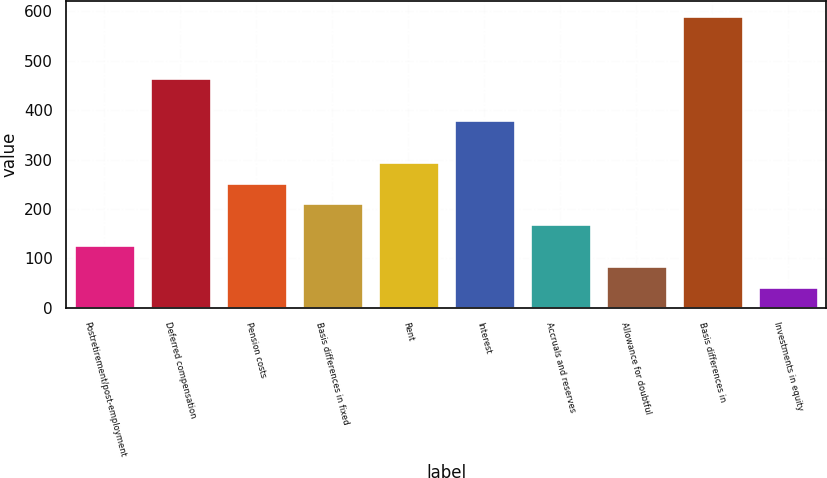Convert chart to OTSL. <chart><loc_0><loc_0><loc_500><loc_500><bar_chart><fcel>Postretirement/post-employment<fcel>Deferred compensation<fcel>Pension costs<fcel>Basis differences in fixed<fcel>Rent<fcel>Interest<fcel>Accruals and reserves<fcel>Allowance for doubtful<fcel>Basis differences in<fcel>Investments in equity<nl><fcel>126.87<fcel>464.39<fcel>253.44<fcel>211.25<fcel>295.63<fcel>380.01<fcel>169.06<fcel>84.68<fcel>590.96<fcel>42.49<nl></chart> 